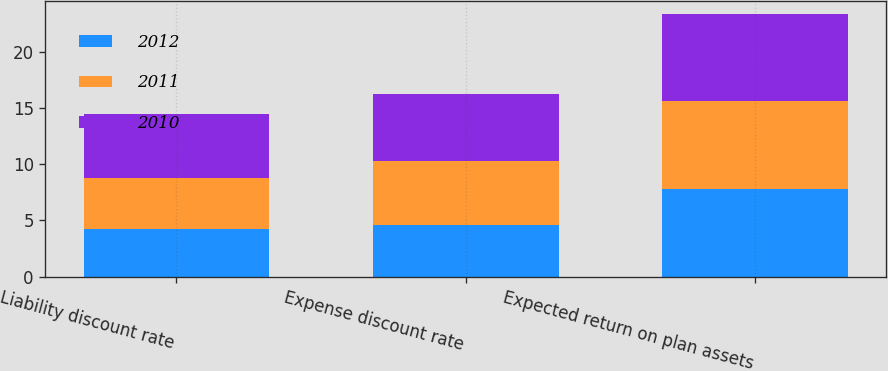<chart> <loc_0><loc_0><loc_500><loc_500><stacked_bar_chart><ecel><fcel>Liability discount rate<fcel>Expense discount rate<fcel>Expected return on plan assets<nl><fcel>2012<fcel>4.2<fcel>4.6<fcel>7.8<nl><fcel>2011<fcel>4.6<fcel>5.7<fcel>7.8<nl><fcel>2010<fcel>5.7<fcel>6<fcel>7.8<nl></chart> 